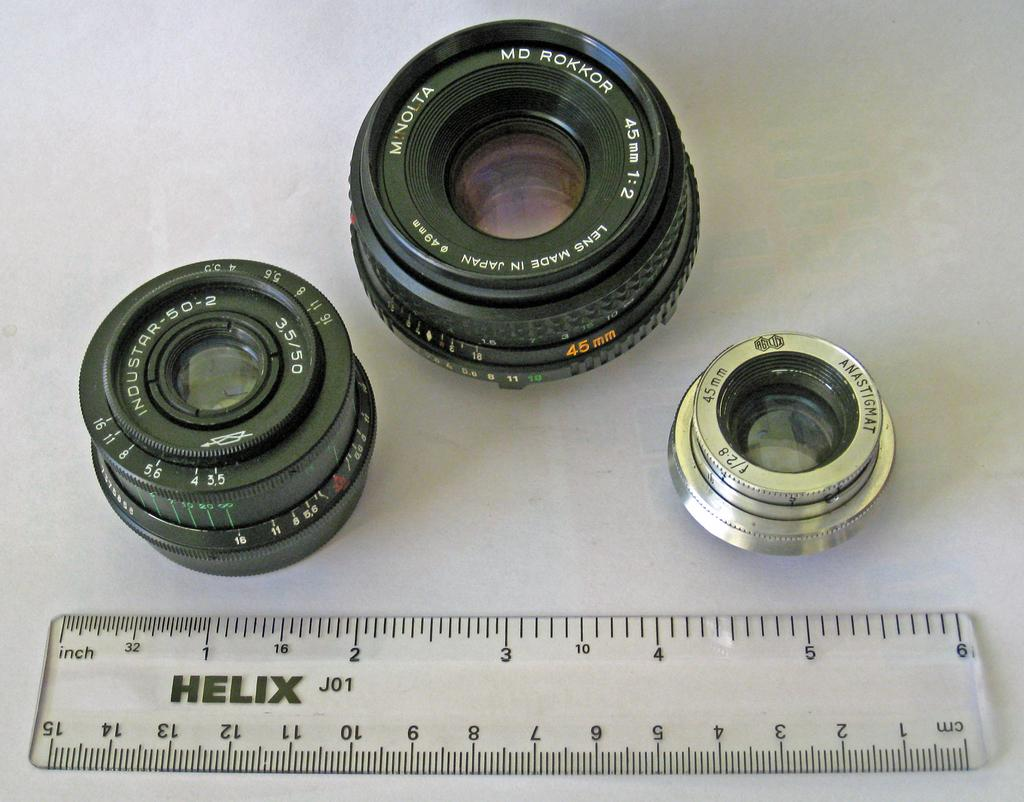Provide a one-sentence caption for the provided image. Three camera lenses in front of a clear Helix brand ruler. 